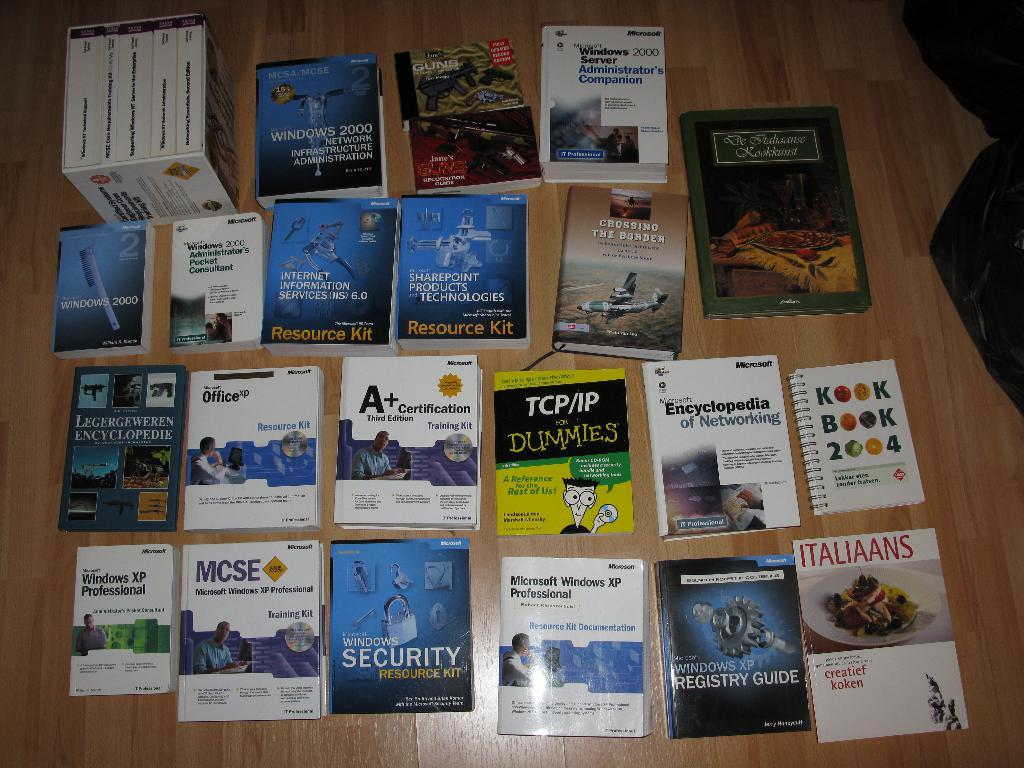<image>
Render a clear and concise summary of the photo. Several books on a table including windows security, TCP/IP for dummies and a handbook on guns. 